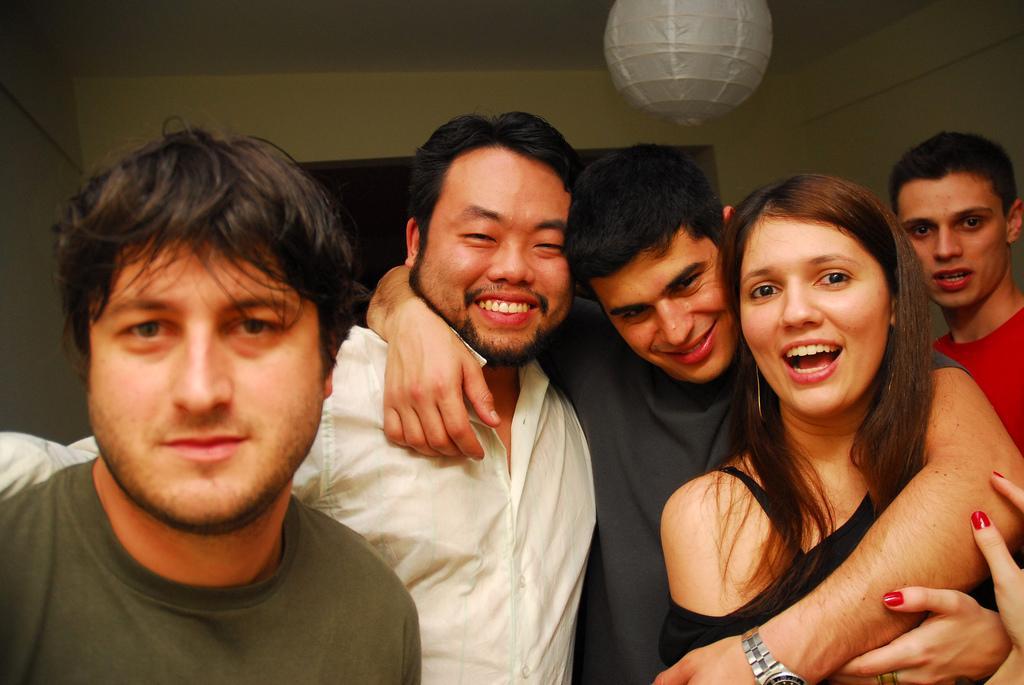Could you give a brief overview of what you see in this image? This picture is clicked inside the room. In the foreground we can see the group of persons standing. In the background we can see the wall. At the top there is a white color object hanging on the roof. 